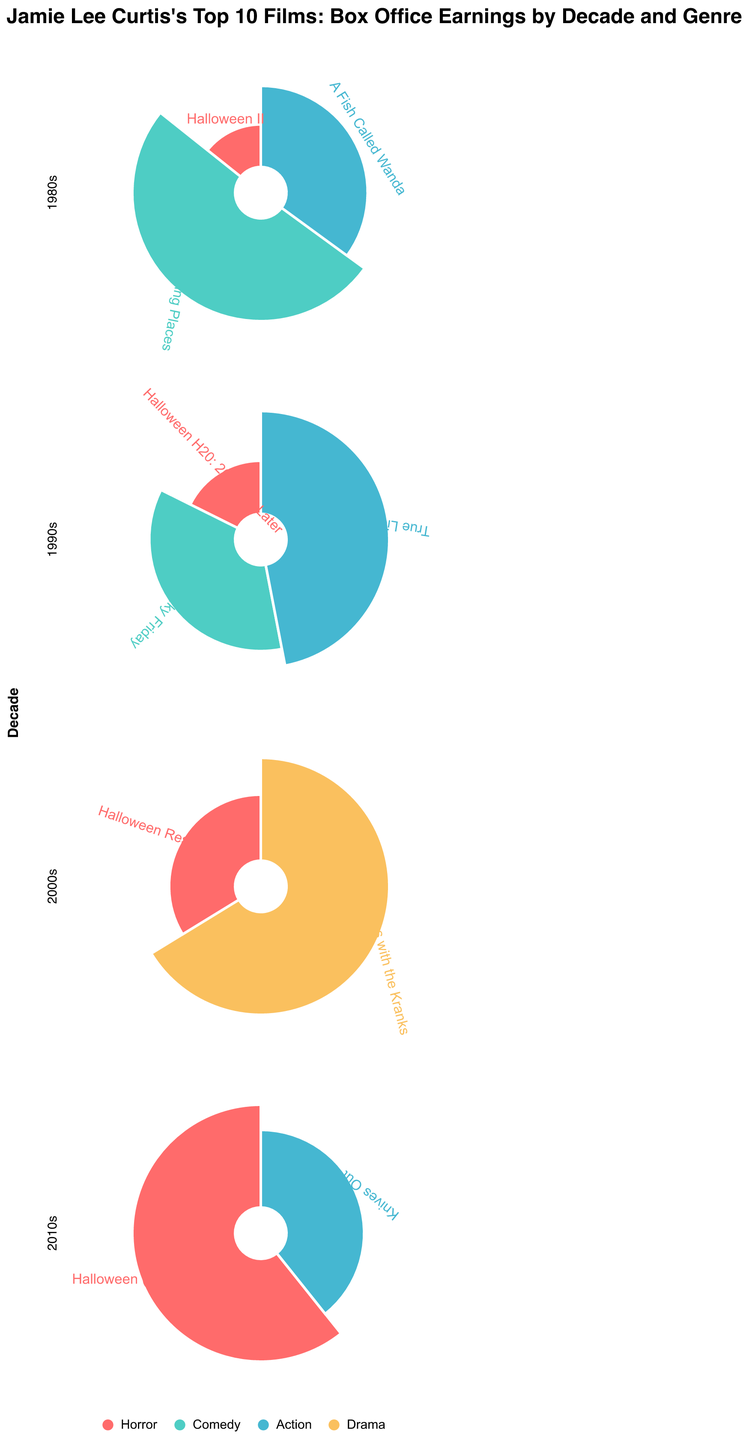Which decade does Jamie Lee Curtis have the highest box office earnings in one film? In the 2010s, Jamie Lee Curtis's film "Halloween (2018)" has the highest box office earnings of $255.6 million.
Answer: 2010s What is the total box office earnings for Jamie Lee Curtis's horror films in the 1980s? Jamie Lee Curtis's horror film in the 1980s is "Halloween II," which has box office earnings of $25.5 million.
Answer: $25.5 million Among the different genres in the 2000s, which genre has the highest box office earnings, and what is the amount? In the 2000s, the genre with the highest box office earnings is Drama ("Christmas with the Kranks") with $73.8 million.
Answer: Drama, $73.8 million Which film earned more, "True Lies" or "Knives Out," and by how much? "True Lies" earned $146.3 million, while "Knives Out" earned $165.3 million. The difference is $165.3 million - $146.3 million = $19 million.
Answer: Knives Out, by $19 million How many films in the 2010s surpass $100 million in box office earnings? In the 2010s, the films "Halloween (2018)" ($255.6 million) and "Knives Out" ($165.3 million) both surpass $100 million.
Answer: 2 Which genre appears most frequently across Jamie Lee Curtis's top 10 films, and how many films does it include? The genre "Horror" appears most frequently, including the films "Halloween II," "Halloween H20: 20 Years Later," "Halloween Resurrection," and "Halloween (2018)."
Answer: Horror, 4 What is the average box office earnings of Jamie Lee Curtis's films in the 1990s? The films in the 1990s are "Halloween H20: 20 Years Later" ($55 million), "Freaky Friday" ($110.2 million), and "True Lies" ($146.3 million). The average is ($55 + $110.2 + $146.3) / 3 = $103.83 million.
Answer: $103.83 million Which decade has the highest total box office earnings for Jamie Lee Curtis's top 10 films? Summing up the box office earnings: 1980s (25.5 + 90.4 + 62.5 = 178.4), 1990s (55 + 110.2 + 146.3 = 311.5), 2000s (73.8 + 37.6 = 111.4), 2010s (255.6 + 165.3 = 420.9). The highest total is in the 2010s.
Answer: 2010s Compare the total earnings of Jamie Lee Curtis's comedy films in the 1980s and 1990s. Which decade's comedies earned more? In the 1980s, comedy ("Trading Places") earned $90.4 million. In the 1990s, comedy ("Freaky Friday") earned $110.2 million. The 1990s earned more.
Answer: 1990s What is the least earning film, and which genre and decade does it belong to? The least earning film is "Halloween II" with $25.5 million, which belongs to the Horror genre in the 1980s.
Answer: Halloween II, Horror, 1980s 